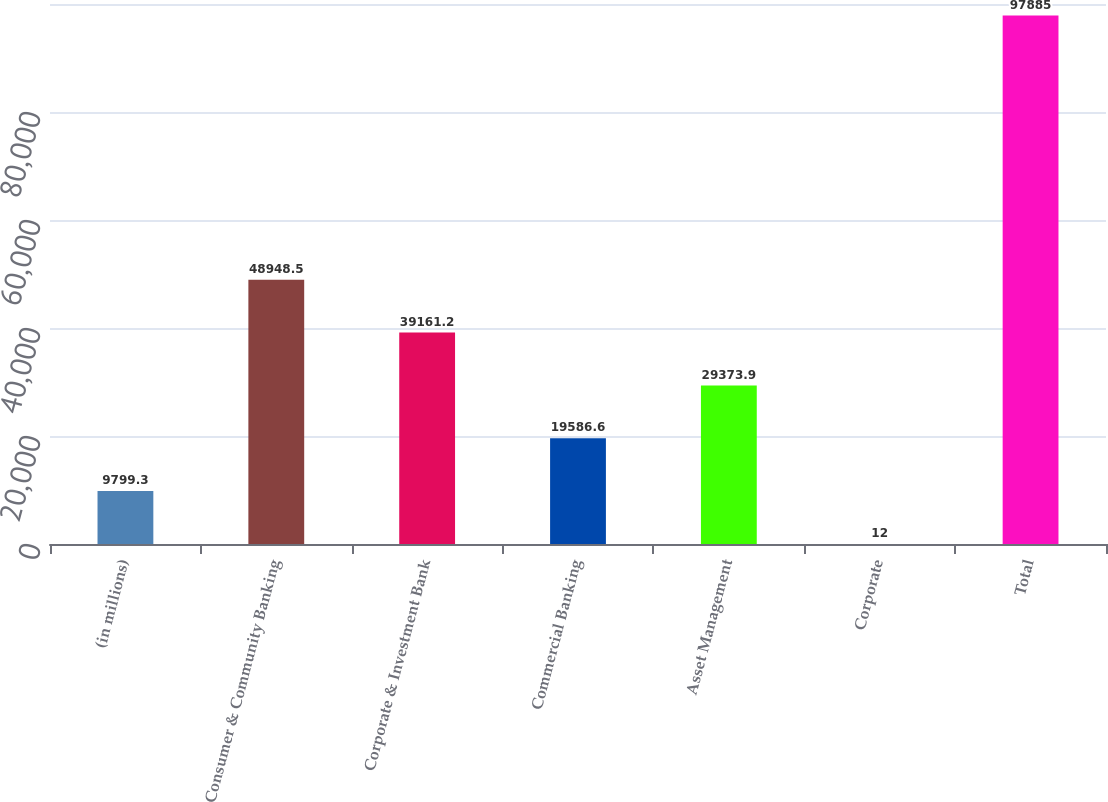Convert chart. <chart><loc_0><loc_0><loc_500><loc_500><bar_chart><fcel>(in millions)<fcel>Consumer & Community Banking<fcel>Corporate & Investment Bank<fcel>Commercial Banking<fcel>Asset Management<fcel>Corporate<fcel>Total<nl><fcel>9799.3<fcel>48948.5<fcel>39161.2<fcel>19586.6<fcel>29373.9<fcel>12<fcel>97885<nl></chart> 